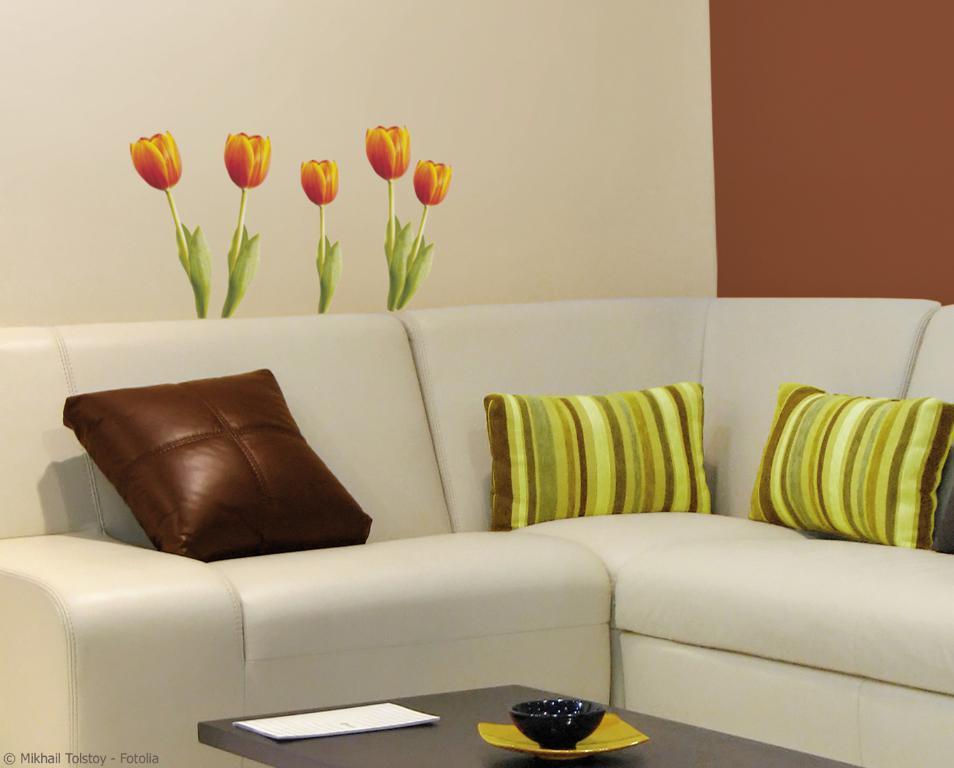Please provide a concise description of this image. This is a picture of a room in which there is a sofa and three pillows on it and a table in front of it and a bowl and a paper and behind the sofa there is a wall painting of five flowers. 